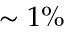Convert formula to latex. <formula><loc_0><loc_0><loc_500><loc_500>\sim 1 \%</formula> 